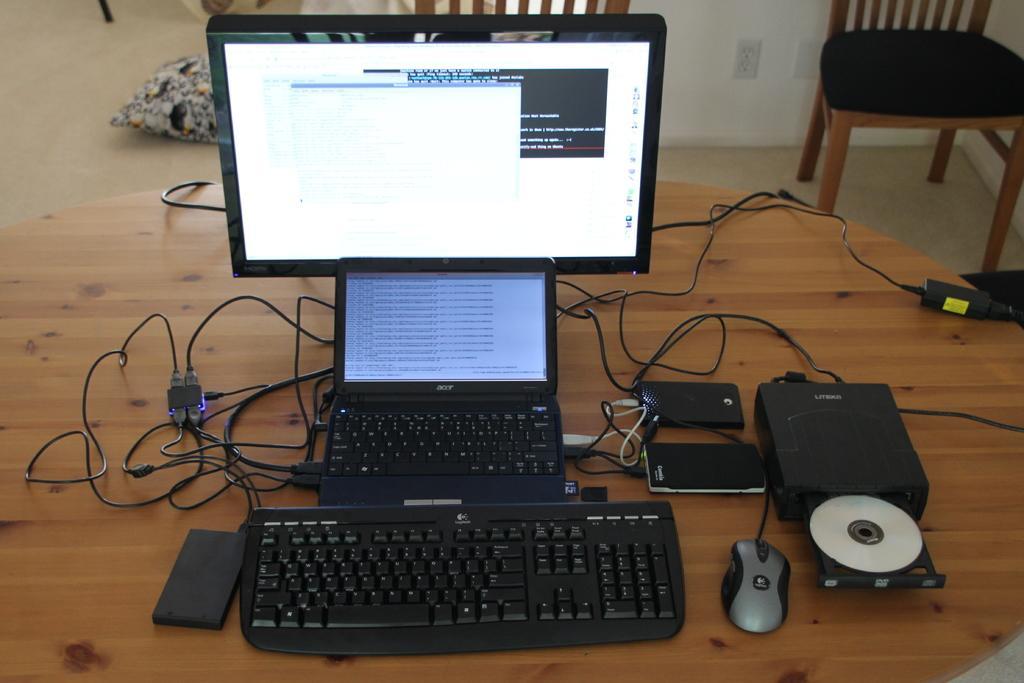Can you describe this image briefly? In this image In the middle there is a table on that there is keyboard, mouse, mobiles, laptop, monitor and wires. In the background there are chairs, pillow, wall and floor. 